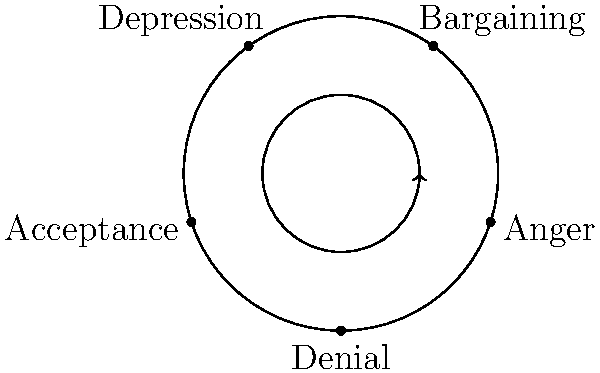As a school counselor experienced in crisis management, you're explaining the stages of grief to a student who has recently lost a loved one. Using the cyclical diagram provided, which stage typically follows "Bargaining" in the grief process? To answer this question, we need to analyze the cyclical diagram of the stages of grief:

1. The diagram shows the five stages of grief: Denial, Anger, Bargaining, Depression, and Acceptance.
2. These stages are arranged in a circular pattern, indicating that the grief process is not always linear and can be cyclical.
3. The arrow in the center suggests that people may move through these stages in a clockwise direction, although it's important to note that individuals may experience these stages in different orders or even revisit stages.
4. To find the stage that typically follows "Bargaining," we need to locate "Bargaining" on the diagram and identify the next stage in the clockwise direction.
5. Looking at the diagram, we can see that "Bargaining" is followed by "Depression."

Therefore, according to the cyclical model of grief presented in this diagram, the stage that typically follows "Bargaining" is Depression.
Answer: Depression 